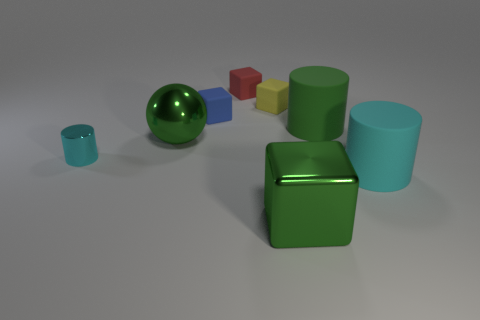Subtract all green blocks. How many cyan cylinders are left? 2 Subtract all cyan cylinders. How many cylinders are left? 1 Subtract all red cubes. How many cubes are left? 3 Add 1 small metallic things. How many objects exist? 9 Subtract all purple cubes. Subtract all cyan spheres. How many cubes are left? 4 Subtract all spheres. How many objects are left? 7 Add 6 tiny brown cubes. How many tiny brown cubes exist? 6 Subtract 1 green spheres. How many objects are left? 7 Subtract all small blue things. Subtract all large green spheres. How many objects are left? 6 Add 6 big green rubber cylinders. How many big green rubber cylinders are left? 7 